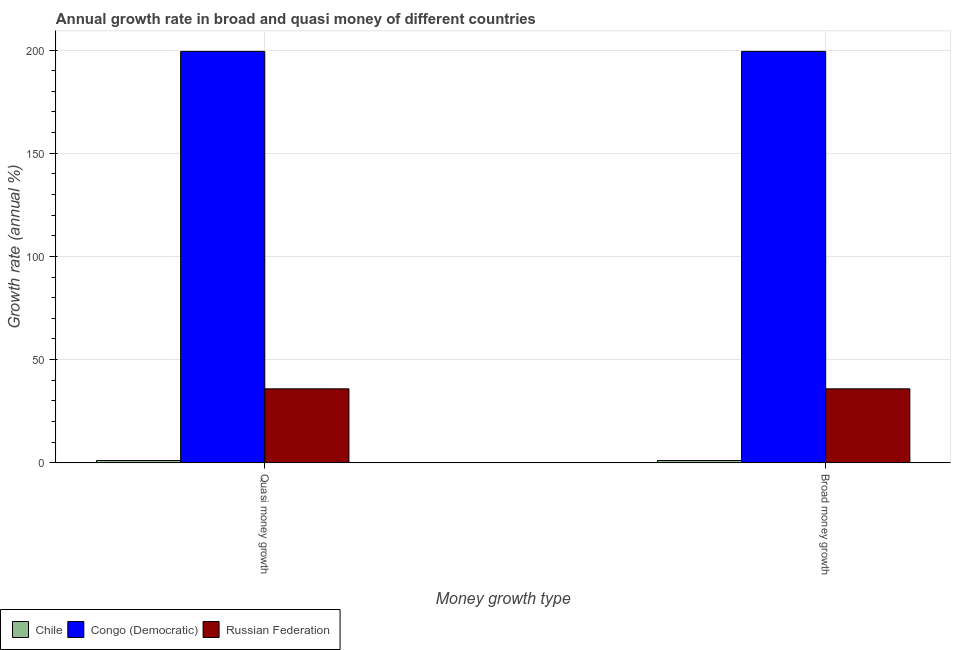How many different coloured bars are there?
Provide a short and direct response. 3. Are the number of bars per tick equal to the number of legend labels?
Provide a succinct answer. Yes. Are the number of bars on each tick of the X-axis equal?
Make the answer very short. Yes. How many bars are there on the 1st tick from the left?
Provide a succinct answer. 3. How many bars are there on the 1st tick from the right?
Make the answer very short. 3. What is the label of the 1st group of bars from the left?
Your answer should be compact. Quasi money growth. What is the annual growth rate in quasi money in Russian Federation?
Offer a terse response. 35.85. Across all countries, what is the maximum annual growth rate in quasi money?
Offer a very short reply. 199.36. Across all countries, what is the minimum annual growth rate in quasi money?
Offer a terse response. 1.11. In which country was the annual growth rate in quasi money maximum?
Keep it short and to the point. Congo (Democratic). In which country was the annual growth rate in quasi money minimum?
Make the answer very short. Chile. What is the total annual growth rate in quasi money in the graph?
Keep it short and to the point. 236.32. What is the difference between the annual growth rate in quasi money in Congo (Democratic) and that in Chile?
Make the answer very short. 198.25. What is the difference between the annual growth rate in quasi money in Russian Federation and the annual growth rate in broad money in Congo (Democratic)?
Keep it short and to the point. -163.52. What is the average annual growth rate in quasi money per country?
Make the answer very short. 78.77. In how many countries, is the annual growth rate in quasi money greater than 80 %?
Make the answer very short. 1. What is the ratio of the annual growth rate in quasi money in Congo (Democratic) to that in Chile?
Keep it short and to the point. 179.1. What does the 2nd bar from the left in Broad money growth represents?
Offer a very short reply. Congo (Democratic). What does the 2nd bar from the right in Broad money growth represents?
Provide a succinct answer. Congo (Democratic). How many bars are there?
Provide a short and direct response. 6. What is the difference between two consecutive major ticks on the Y-axis?
Your answer should be very brief. 50. Are the values on the major ticks of Y-axis written in scientific E-notation?
Provide a short and direct response. No. Does the graph contain any zero values?
Keep it short and to the point. No. Does the graph contain grids?
Offer a very short reply. Yes. How many legend labels are there?
Your response must be concise. 3. How are the legend labels stacked?
Offer a very short reply. Horizontal. What is the title of the graph?
Give a very brief answer. Annual growth rate in broad and quasi money of different countries. What is the label or title of the X-axis?
Give a very brief answer. Money growth type. What is the label or title of the Y-axis?
Offer a terse response. Growth rate (annual %). What is the Growth rate (annual %) of Chile in Quasi money growth?
Ensure brevity in your answer.  1.11. What is the Growth rate (annual %) of Congo (Democratic) in Quasi money growth?
Your answer should be compact. 199.36. What is the Growth rate (annual %) in Russian Federation in Quasi money growth?
Offer a terse response. 35.85. What is the Growth rate (annual %) in Chile in Broad money growth?
Provide a short and direct response. 1.11. What is the Growth rate (annual %) of Congo (Democratic) in Broad money growth?
Your answer should be compact. 199.36. What is the Growth rate (annual %) of Russian Federation in Broad money growth?
Keep it short and to the point. 35.85. Across all Money growth type, what is the maximum Growth rate (annual %) in Chile?
Keep it short and to the point. 1.11. Across all Money growth type, what is the maximum Growth rate (annual %) in Congo (Democratic)?
Ensure brevity in your answer.  199.36. Across all Money growth type, what is the maximum Growth rate (annual %) of Russian Federation?
Provide a short and direct response. 35.85. Across all Money growth type, what is the minimum Growth rate (annual %) of Chile?
Make the answer very short. 1.11. Across all Money growth type, what is the minimum Growth rate (annual %) of Congo (Democratic)?
Offer a very short reply. 199.36. Across all Money growth type, what is the minimum Growth rate (annual %) in Russian Federation?
Offer a terse response. 35.85. What is the total Growth rate (annual %) of Chile in the graph?
Provide a succinct answer. 2.23. What is the total Growth rate (annual %) of Congo (Democratic) in the graph?
Make the answer very short. 398.73. What is the total Growth rate (annual %) of Russian Federation in the graph?
Ensure brevity in your answer.  71.69. What is the difference between the Growth rate (annual %) in Russian Federation in Quasi money growth and that in Broad money growth?
Offer a very short reply. 0. What is the difference between the Growth rate (annual %) in Chile in Quasi money growth and the Growth rate (annual %) in Congo (Democratic) in Broad money growth?
Your answer should be very brief. -198.25. What is the difference between the Growth rate (annual %) of Chile in Quasi money growth and the Growth rate (annual %) of Russian Federation in Broad money growth?
Give a very brief answer. -34.73. What is the difference between the Growth rate (annual %) of Congo (Democratic) in Quasi money growth and the Growth rate (annual %) of Russian Federation in Broad money growth?
Your answer should be very brief. 163.52. What is the average Growth rate (annual %) in Chile per Money growth type?
Give a very brief answer. 1.11. What is the average Growth rate (annual %) of Congo (Democratic) per Money growth type?
Your answer should be compact. 199.36. What is the average Growth rate (annual %) of Russian Federation per Money growth type?
Offer a very short reply. 35.85. What is the difference between the Growth rate (annual %) of Chile and Growth rate (annual %) of Congo (Democratic) in Quasi money growth?
Ensure brevity in your answer.  -198.25. What is the difference between the Growth rate (annual %) of Chile and Growth rate (annual %) of Russian Federation in Quasi money growth?
Make the answer very short. -34.73. What is the difference between the Growth rate (annual %) of Congo (Democratic) and Growth rate (annual %) of Russian Federation in Quasi money growth?
Your answer should be very brief. 163.52. What is the difference between the Growth rate (annual %) in Chile and Growth rate (annual %) in Congo (Democratic) in Broad money growth?
Give a very brief answer. -198.25. What is the difference between the Growth rate (annual %) of Chile and Growth rate (annual %) of Russian Federation in Broad money growth?
Your answer should be very brief. -34.73. What is the difference between the Growth rate (annual %) in Congo (Democratic) and Growth rate (annual %) in Russian Federation in Broad money growth?
Offer a terse response. 163.52. What is the ratio of the Growth rate (annual %) of Chile in Quasi money growth to that in Broad money growth?
Ensure brevity in your answer.  1. What is the ratio of the Growth rate (annual %) in Russian Federation in Quasi money growth to that in Broad money growth?
Ensure brevity in your answer.  1. What is the difference between the highest and the second highest Growth rate (annual %) of Chile?
Make the answer very short. 0. What is the difference between the highest and the second highest Growth rate (annual %) of Congo (Democratic)?
Your response must be concise. 0. What is the difference between the highest and the lowest Growth rate (annual %) of Chile?
Offer a terse response. 0. What is the difference between the highest and the lowest Growth rate (annual %) in Congo (Democratic)?
Your answer should be compact. 0. What is the difference between the highest and the lowest Growth rate (annual %) of Russian Federation?
Give a very brief answer. 0. 